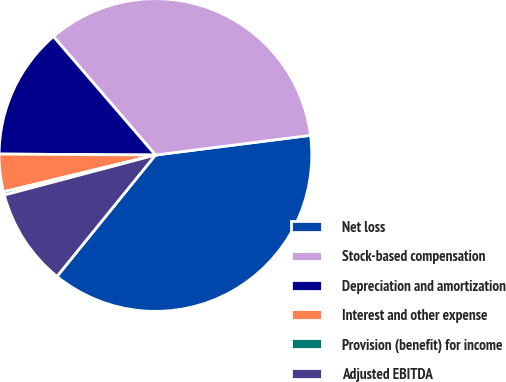<chart> <loc_0><loc_0><loc_500><loc_500><pie_chart><fcel>Net loss<fcel>Stock-based compensation<fcel>Depreciation and amortization<fcel>Interest and other expense<fcel>Provision (benefit) for income<fcel>Adjusted EBITDA<nl><fcel>37.86%<fcel>34.3%<fcel>13.59%<fcel>3.89%<fcel>0.33%<fcel>10.03%<nl></chart> 